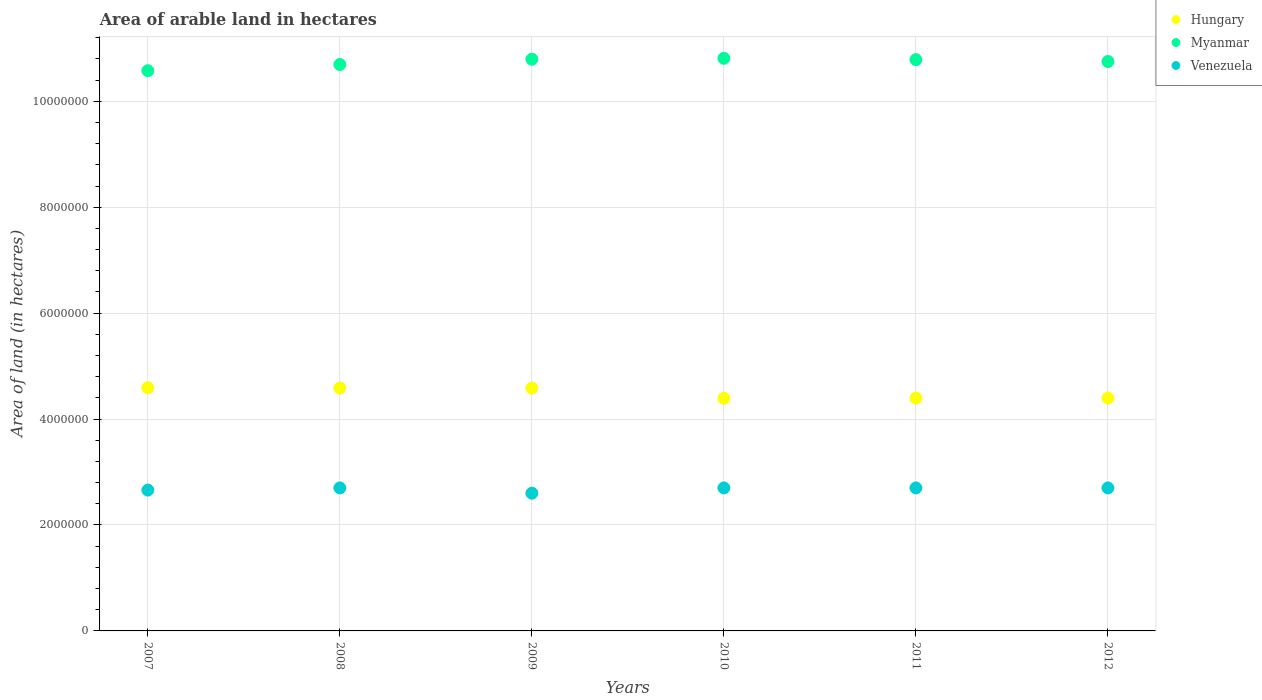What is the total arable land in Myanmar in 2010?
Provide a short and direct response. 1.08e+07. Across all years, what is the maximum total arable land in Hungary?
Offer a very short reply. 4.59e+06. Across all years, what is the minimum total arable land in Venezuela?
Offer a very short reply. 2.60e+06. In which year was the total arable land in Venezuela minimum?
Your answer should be compact. 2009. What is the total total arable land in Hungary in the graph?
Make the answer very short. 2.69e+07. What is the difference between the total arable land in Myanmar in 2011 and the total arable land in Hungary in 2008?
Provide a succinct answer. 6.20e+06. What is the average total arable land in Hungary per year?
Your response must be concise. 4.49e+06. In the year 2008, what is the difference between the total arable land in Venezuela and total arable land in Hungary?
Your answer should be very brief. -1.88e+06. What is the ratio of the total arable land in Venezuela in 2007 to that in 2010?
Your answer should be compact. 0.98. Is the total arable land in Hungary in 2007 less than that in 2011?
Provide a succinct answer. No. Is the difference between the total arable land in Venezuela in 2007 and 2012 greater than the difference between the total arable land in Hungary in 2007 and 2012?
Offer a very short reply. No. What is the difference between the highest and the second highest total arable land in Myanmar?
Your response must be concise. 1.70e+04. What is the difference between the highest and the lowest total arable land in Venezuela?
Keep it short and to the point. 1.00e+05. Is the sum of the total arable land in Venezuela in 2011 and 2012 greater than the maximum total arable land in Hungary across all years?
Ensure brevity in your answer.  Yes. Is the total arable land in Myanmar strictly greater than the total arable land in Hungary over the years?
Offer a very short reply. Yes. How many dotlines are there?
Offer a very short reply. 3. Does the graph contain any zero values?
Make the answer very short. No. Does the graph contain grids?
Your answer should be very brief. Yes. Where does the legend appear in the graph?
Provide a succinct answer. Top right. How many legend labels are there?
Give a very brief answer. 3. What is the title of the graph?
Give a very brief answer. Area of arable land in hectares. What is the label or title of the Y-axis?
Offer a terse response. Area of land (in hectares). What is the Area of land (in hectares) in Hungary in 2007?
Keep it short and to the point. 4.59e+06. What is the Area of land (in hectares) of Myanmar in 2007?
Your response must be concise. 1.06e+07. What is the Area of land (in hectares) in Venezuela in 2007?
Make the answer very short. 2.66e+06. What is the Area of land (in hectares) in Hungary in 2008?
Keep it short and to the point. 4.58e+06. What is the Area of land (in hectares) of Myanmar in 2008?
Keep it short and to the point. 1.07e+07. What is the Area of land (in hectares) of Venezuela in 2008?
Offer a terse response. 2.70e+06. What is the Area of land (in hectares) of Hungary in 2009?
Your answer should be compact. 4.58e+06. What is the Area of land (in hectares) of Myanmar in 2009?
Your answer should be very brief. 1.08e+07. What is the Area of land (in hectares) in Venezuela in 2009?
Offer a very short reply. 2.60e+06. What is the Area of land (in hectares) in Hungary in 2010?
Your answer should be compact. 4.39e+06. What is the Area of land (in hectares) in Myanmar in 2010?
Give a very brief answer. 1.08e+07. What is the Area of land (in hectares) in Venezuela in 2010?
Your answer should be very brief. 2.70e+06. What is the Area of land (in hectares) of Hungary in 2011?
Give a very brief answer. 4.40e+06. What is the Area of land (in hectares) in Myanmar in 2011?
Offer a terse response. 1.08e+07. What is the Area of land (in hectares) in Venezuela in 2011?
Your answer should be very brief. 2.70e+06. What is the Area of land (in hectares) of Hungary in 2012?
Provide a short and direct response. 4.40e+06. What is the Area of land (in hectares) in Myanmar in 2012?
Your answer should be compact. 1.08e+07. What is the Area of land (in hectares) of Venezuela in 2012?
Provide a short and direct response. 2.70e+06. Across all years, what is the maximum Area of land (in hectares) in Hungary?
Keep it short and to the point. 4.59e+06. Across all years, what is the maximum Area of land (in hectares) of Myanmar?
Your answer should be very brief. 1.08e+07. Across all years, what is the maximum Area of land (in hectares) of Venezuela?
Your answer should be compact. 2.70e+06. Across all years, what is the minimum Area of land (in hectares) in Hungary?
Make the answer very short. 4.39e+06. Across all years, what is the minimum Area of land (in hectares) in Myanmar?
Offer a very short reply. 1.06e+07. Across all years, what is the minimum Area of land (in hectares) of Venezuela?
Offer a terse response. 2.60e+06. What is the total Area of land (in hectares) in Hungary in the graph?
Your response must be concise. 2.69e+07. What is the total Area of land (in hectares) of Myanmar in the graph?
Offer a very short reply. 6.44e+07. What is the total Area of land (in hectares) in Venezuela in the graph?
Your answer should be very brief. 1.61e+07. What is the difference between the Area of land (in hectares) in Hungary in 2007 and that in 2008?
Your answer should be very brief. 7000. What is the difference between the Area of land (in hectares) in Myanmar in 2007 and that in 2008?
Your answer should be very brief. -1.17e+05. What is the difference between the Area of land (in hectares) of Venezuela in 2007 and that in 2008?
Offer a terse response. -4.10e+04. What is the difference between the Area of land (in hectares) in Hungary in 2007 and that in 2009?
Offer a terse response. 7000. What is the difference between the Area of land (in hectares) in Myanmar in 2007 and that in 2009?
Your answer should be compact. -2.17e+05. What is the difference between the Area of land (in hectares) in Venezuela in 2007 and that in 2009?
Keep it short and to the point. 5.90e+04. What is the difference between the Area of land (in hectares) of Myanmar in 2007 and that in 2010?
Your response must be concise. -2.34e+05. What is the difference between the Area of land (in hectares) in Venezuela in 2007 and that in 2010?
Ensure brevity in your answer.  -4.10e+04. What is the difference between the Area of land (in hectares) in Hungary in 2007 and that in 2011?
Provide a short and direct response. 1.97e+05. What is the difference between the Area of land (in hectares) of Myanmar in 2007 and that in 2011?
Make the answer very short. -2.09e+05. What is the difference between the Area of land (in hectares) in Venezuela in 2007 and that in 2011?
Keep it short and to the point. -4.10e+04. What is the difference between the Area of land (in hectares) in Hungary in 2007 and that in 2012?
Give a very brief answer. 1.95e+05. What is the difference between the Area of land (in hectares) in Myanmar in 2007 and that in 2012?
Give a very brief answer. -1.74e+05. What is the difference between the Area of land (in hectares) in Venezuela in 2007 and that in 2012?
Keep it short and to the point. -4.10e+04. What is the difference between the Area of land (in hectares) of Hungary in 2008 and that in 2010?
Keep it short and to the point. 1.93e+05. What is the difference between the Area of land (in hectares) of Myanmar in 2008 and that in 2010?
Provide a short and direct response. -1.17e+05. What is the difference between the Area of land (in hectares) in Hungary in 2008 and that in 2011?
Your response must be concise. 1.90e+05. What is the difference between the Area of land (in hectares) in Myanmar in 2008 and that in 2011?
Offer a terse response. -9.20e+04. What is the difference between the Area of land (in hectares) of Venezuela in 2008 and that in 2011?
Provide a succinct answer. 0. What is the difference between the Area of land (in hectares) in Hungary in 2008 and that in 2012?
Keep it short and to the point. 1.88e+05. What is the difference between the Area of land (in hectares) in Myanmar in 2008 and that in 2012?
Ensure brevity in your answer.  -5.70e+04. What is the difference between the Area of land (in hectares) in Hungary in 2009 and that in 2010?
Your answer should be very brief. 1.93e+05. What is the difference between the Area of land (in hectares) in Myanmar in 2009 and that in 2010?
Offer a very short reply. -1.70e+04. What is the difference between the Area of land (in hectares) of Hungary in 2009 and that in 2011?
Give a very brief answer. 1.90e+05. What is the difference between the Area of land (in hectares) of Myanmar in 2009 and that in 2011?
Your answer should be compact. 8000. What is the difference between the Area of land (in hectares) in Venezuela in 2009 and that in 2011?
Offer a terse response. -1.00e+05. What is the difference between the Area of land (in hectares) in Hungary in 2009 and that in 2012?
Keep it short and to the point. 1.88e+05. What is the difference between the Area of land (in hectares) of Myanmar in 2009 and that in 2012?
Ensure brevity in your answer.  4.30e+04. What is the difference between the Area of land (in hectares) of Hungary in 2010 and that in 2011?
Make the answer very short. -3000. What is the difference between the Area of land (in hectares) in Myanmar in 2010 and that in 2011?
Provide a succinct answer. 2.50e+04. What is the difference between the Area of land (in hectares) of Venezuela in 2010 and that in 2011?
Offer a terse response. 0. What is the difference between the Area of land (in hectares) in Hungary in 2010 and that in 2012?
Keep it short and to the point. -5000. What is the difference between the Area of land (in hectares) of Myanmar in 2010 and that in 2012?
Keep it short and to the point. 6.00e+04. What is the difference between the Area of land (in hectares) in Hungary in 2011 and that in 2012?
Make the answer very short. -2000. What is the difference between the Area of land (in hectares) in Myanmar in 2011 and that in 2012?
Make the answer very short. 3.50e+04. What is the difference between the Area of land (in hectares) of Venezuela in 2011 and that in 2012?
Your answer should be very brief. 0. What is the difference between the Area of land (in hectares) in Hungary in 2007 and the Area of land (in hectares) in Myanmar in 2008?
Your answer should be very brief. -6.10e+06. What is the difference between the Area of land (in hectares) of Hungary in 2007 and the Area of land (in hectares) of Venezuela in 2008?
Offer a terse response. 1.89e+06. What is the difference between the Area of land (in hectares) of Myanmar in 2007 and the Area of land (in hectares) of Venezuela in 2008?
Your answer should be compact. 7.88e+06. What is the difference between the Area of land (in hectares) of Hungary in 2007 and the Area of land (in hectares) of Myanmar in 2009?
Your answer should be compact. -6.20e+06. What is the difference between the Area of land (in hectares) in Hungary in 2007 and the Area of land (in hectares) in Venezuela in 2009?
Offer a very short reply. 1.99e+06. What is the difference between the Area of land (in hectares) of Myanmar in 2007 and the Area of land (in hectares) of Venezuela in 2009?
Make the answer very short. 7.98e+06. What is the difference between the Area of land (in hectares) of Hungary in 2007 and the Area of land (in hectares) of Myanmar in 2010?
Offer a terse response. -6.22e+06. What is the difference between the Area of land (in hectares) in Hungary in 2007 and the Area of land (in hectares) in Venezuela in 2010?
Your response must be concise. 1.89e+06. What is the difference between the Area of land (in hectares) in Myanmar in 2007 and the Area of land (in hectares) in Venezuela in 2010?
Give a very brief answer. 7.88e+06. What is the difference between the Area of land (in hectares) of Hungary in 2007 and the Area of land (in hectares) of Myanmar in 2011?
Your response must be concise. -6.19e+06. What is the difference between the Area of land (in hectares) in Hungary in 2007 and the Area of land (in hectares) in Venezuela in 2011?
Make the answer very short. 1.89e+06. What is the difference between the Area of land (in hectares) of Myanmar in 2007 and the Area of land (in hectares) of Venezuela in 2011?
Ensure brevity in your answer.  7.88e+06. What is the difference between the Area of land (in hectares) in Hungary in 2007 and the Area of land (in hectares) in Myanmar in 2012?
Your answer should be very brief. -6.16e+06. What is the difference between the Area of land (in hectares) of Hungary in 2007 and the Area of land (in hectares) of Venezuela in 2012?
Give a very brief answer. 1.89e+06. What is the difference between the Area of land (in hectares) in Myanmar in 2007 and the Area of land (in hectares) in Venezuela in 2012?
Offer a terse response. 7.88e+06. What is the difference between the Area of land (in hectares) in Hungary in 2008 and the Area of land (in hectares) in Myanmar in 2009?
Offer a terse response. -6.21e+06. What is the difference between the Area of land (in hectares) in Hungary in 2008 and the Area of land (in hectares) in Venezuela in 2009?
Your answer should be very brief. 1.98e+06. What is the difference between the Area of land (in hectares) in Myanmar in 2008 and the Area of land (in hectares) in Venezuela in 2009?
Keep it short and to the point. 8.09e+06. What is the difference between the Area of land (in hectares) in Hungary in 2008 and the Area of land (in hectares) in Myanmar in 2010?
Provide a short and direct response. -6.23e+06. What is the difference between the Area of land (in hectares) in Hungary in 2008 and the Area of land (in hectares) in Venezuela in 2010?
Offer a terse response. 1.88e+06. What is the difference between the Area of land (in hectares) of Myanmar in 2008 and the Area of land (in hectares) of Venezuela in 2010?
Keep it short and to the point. 7.99e+06. What is the difference between the Area of land (in hectares) of Hungary in 2008 and the Area of land (in hectares) of Myanmar in 2011?
Provide a short and direct response. -6.20e+06. What is the difference between the Area of land (in hectares) in Hungary in 2008 and the Area of land (in hectares) in Venezuela in 2011?
Offer a terse response. 1.88e+06. What is the difference between the Area of land (in hectares) of Myanmar in 2008 and the Area of land (in hectares) of Venezuela in 2011?
Keep it short and to the point. 7.99e+06. What is the difference between the Area of land (in hectares) of Hungary in 2008 and the Area of land (in hectares) of Myanmar in 2012?
Your answer should be compact. -6.17e+06. What is the difference between the Area of land (in hectares) in Hungary in 2008 and the Area of land (in hectares) in Venezuela in 2012?
Offer a terse response. 1.88e+06. What is the difference between the Area of land (in hectares) of Myanmar in 2008 and the Area of land (in hectares) of Venezuela in 2012?
Give a very brief answer. 7.99e+06. What is the difference between the Area of land (in hectares) in Hungary in 2009 and the Area of land (in hectares) in Myanmar in 2010?
Offer a very short reply. -6.23e+06. What is the difference between the Area of land (in hectares) of Hungary in 2009 and the Area of land (in hectares) of Venezuela in 2010?
Ensure brevity in your answer.  1.88e+06. What is the difference between the Area of land (in hectares) in Myanmar in 2009 and the Area of land (in hectares) in Venezuela in 2010?
Provide a succinct answer. 8.09e+06. What is the difference between the Area of land (in hectares) of Hungary in 2009 and the Area of land (in hectares) of Myanmar in 2011?
Keep it short and to the point. -6.20e+06. What is the difference between the Area of land (in hectares) in Hungary in 2009 and the Area of land (in hectares) in Venezuela in 2011?
Keep it short and to the point. 1.88e+06. What is the difference between the Area of land (in hectares) in Myanmar in 2009 and the Area of land (in hectares) in Venezuela in 2011?
Your response must be concise. 8.09e+06. What is the difference between the Area of land (in hectares) of Hungary in 2009 and the Area of land (in hectares) of Myanmar in 2012?
Offer a terse response. -6.17e+06. What is the difference between the Area of land (in hectares) in Hungary in 2009 and the Area of land (in hectares) in Venezuela in 2012?
Give a very brief answer. 1.88e+06. What is the difference between the Area of land (in hectares) in Myanmar in 2009 and the Area of land (in hectares) in Venezuela in 2012?
Offer a very short reply. 8.09e+06. What is the difference between the Area of land (in hectares) in Hungary in 2010 and the Area of land (in hectares) in Myanmar in 2011?
Your answer should be compact. -6.39e+06. What is the difference between the Area of land (in hectares) of Hungary in 2010 and the Area of land (in hectares) of Venezuela in 2011?
Offer a terse response. 1.69e+06. What is the difference between the Area of land (in hectares) in Myanmar in 2010 and the Area of land (in hectares) in Venezuela in 2011?
Your answer should be very brief. 8.11e+06. What is the difference between the Area of land (in hectares) of Hungary in 2010 and the Area of land (in hectares) of Myanmar in 2012?
Your answer should be compact. -6.36e+06. What is the difference between the Area of land (in hectares) in Hungary in 2010 and the Area of land (in hectares) in Venezuela in 2012?
Give a very brief answer. 1.69e+06. What is the difference between the Area of land (in hectares) in Myanmar in 2010 and the Area of land (in hectares) in Venezuela in 2012?
Keep it short and to the point. 8.11e+06. What is the difference between the Area of land (in hectares) in Hungary in 2011 and the Area of land (in hectares) in Myanmar in 2012?
Your answer should be compact. -6.36e+06. What is the difference between the Area of land (in hectares) of Hungary in 2011 and the Area of land (in hectares) of Venezuela in 2012?
Provide a short and direct response. 1.70e+06. What is the difference between the Area of land (in hectares) in Myanmar in 2011 and the Area of land (in hectares) in Venezuela in 2012?
Offer a terse response. 8.09e+06. What is the average Area of land (in hectares) in Hungary per year?
Offer a terse response. 4.49e+06. What is the average Area of land (in hectares) in Myanmar per year?
Your answer should be very brief. 1.07e+07. What is the average Area of land (in hectares) in Venezuela per year?
Provide a succinct answer. 2.68e+06. In the year 2007, what is the difference between the Area of land (in hectares) of Hungary and Area of land (in hectares) of Myanmar?
Give a very brief answer. -5.98e+06. In the year 2007, what is the difference between the Area of land (in hectares) in Hungary and Area of land (in hectares) in Venezuela?
Your response must be concise. 1.93e+06. In the year 2007, what is the difference between the Area of land (in hectares) in Myanmar and Area of land (in hectares) in Venezuela?
Make the answer very short. 7.92e+06. In the year 2008, what is the difference between the Area of land (in hectares) of Hungary and Area of land (in hectares) of Myanmar?
Provide a short and direct response. -6.11e+06. In the year 2008, what is the difference between the Area of land (in hectares) in Hungary and Area of land (in hectares) in Venezuela?
Your answer should be compact. 1.88e+06. In the year 2008, what is the difference between the Area of land (in hectares) of Myanmar and Area of land (in hectares) of Venezuela?
Keep it short and to the point. 7.99e+06. In the year 2009, what is the difference between the Area of land (in hectares) of Hungary and Area of land (in hectares) of Myanmar?
Your answer should be compact. -6.21e+06. In the year 2009, what is the difference between the Area of land (in hectares) in Hungary and Area of land (in hectares) in Venezuela?
Make the answer very short. 1.98e+06. In the year 2009, what is the difference between the Area of land (in hectares) in Myanmar and Area of land (in hectares) in Venezuela?
Your answer should be very brief. 8.19e+06. In the year 2010, what is the difference between the Area of land (in hectares) in Hungary and Area of land (in hectares) in Myanmar?
Your answer should be very brief. -6.42e+06. In the year 2010, what is the difference between the Area of land (in hectares) of Hungary and Area of land (in hectares) of Venezuela?
Offer a terse response. 1.69e+06. In the year 2010, what is the difference between the Area of land (in hectares) in Myanmar and Area of land (in hectares) in Venezuela?
Make the answer very short. 8.11e+06. In the year 2011, what is the difference between the Area of land (in hectares) in Hungary and Area of land (in hectares) in Myanmar?
Give a very brief answer. -6.39e+06. In the year 2011, what is the difference between the Area of land (in hectares) in Hungary and Area of land (in hectares) in Venezuela?
Give a very brief answer. 1.70e+06. In the year 2011, what is the difference between the Area of land (in hectares) in Myanmar and Area of land (in hectares) in Venezuela?
Your answer should be very brief. 8.09e+06. In the year 2012, what is the difference between the Area of land (in hectares) in Hungary and Area of land (in hectares) in Myanmar?
Your answer should be compact. -6.35e+06. In the year 2012, what is the difference between the Area of land (in hectares) of Hungary and Area of land (in hectares) of Venezuela?
Your answer should be compact. 1.70e+06. In the year 2012, what is the difference between the Area of land (in hectares) in Myanmar and Area of land (in hectares) in Venezuela?
Provide a succinct answer. 8.05e+06. What is the ratio of the Area of land (in hectares) of Hungary in 2007 to that in 2008?
Keep it short and to the point. 1. What is the ratio of the Area of land (in hectares) in Venezuela in 2007 to that in 2008?
Provide a short and direct response. 0.98. What is the ratio of the Area of land (in hectares) of Myanmar in 2007 to that in 2009?
Your response must be concise. 0.98. What is the ratio of the Area of land (in hectares) of Venezuela in 2007 to that in 2009?
Provide a succinct answer. 1.02. What is the ratio of the Area of land (in hectares) in Hungary in 2007 to that in 2010?
Offer a terse response. 1.05. What is the ratio of the Area of land (in hectares) of Myanmar in 2007 to that in 2010?
Offer a very short reply. 0.98. What is the ratio of the Area of land (in hectares) of Hungary in 2007 to that in 2011?
Provide a succinct answer. 1.04. What is the ratio of the Area of land (in hectares) in Myanmar in 2007 to that in 2011?
Provide a succinct answer. 0.98. What is the ratio of the Area of land (in hectares) in Venezuela in 2007 to that in 2011?
Provide a succinct answer. 0.98. What is the ratio of the Area of land (in hectares) in Hungary in 2007 to that in 2012?
Provide a succinct answer. 1.04. What is the ratio of the Area of land (in hectares) in Myanmar in 2007 to that in 2012?
Offer a terse response. 0.98. What is the ratio of the Area of land (in hectares) in Myanmar in 2008 to that in 2009?
Ensure brevity in your answer.  0.99. What is the ratio of the Area of land (in hectares) in Venezuela in 2008 to that in 2009?
Provide a short and direct response. 1.04. What is the ratio of the Area of land (in hectares) in Hungary in 2008 to that in 2010?
Provide a short and direct response. 1.04. What is the ratio of the Area of land (in hectares) of Myanmar in 2008 to that in 2010?
Offer a very short reply. 0.99. What is the ratio of the Area of land (in hectares) in Hungary in 2008 to that in 2011?
Your response must be concise. 1.04. What is the ratio of the Area of land (in hectares) in Myanmar in 2008 to that in 2011?
Keep it short and to the point. 0.99. What is the ratio of the Area of land (in hectares) of Hungary in 2008 to that in 2012?
Ensure brevity in your answer.  1.04. What is the ratio of the Area of land (in hectares) of Myanmar in 2008 to that in 2012?
Offer a terse response. 0.99. What is the ratio of the Area of land (in hectares) of Hungary in 2009 to that in 2010?
Keep it short and to the point. 1.04. What is the ratio of the Area of land (in hectares) in Hungary in 2009 to that in 2011?
Make the answer very short. 1.04. What is the ratio of the Area of land (in hectares) in Myanmar in 2009 to that in 2011?
Give a very brief answer. 1. What is the ratio of the Area of land (in hectares) of Venezuela in 2009 to that in 2011?
Offer a very short reply. 0.96. What is the ratio of the Area of land (in hectares) in Hungary in 2009 to that in 2012?
Your answer should be compact. 1.04. What is the ratio of the Area of land (in hectares) in Myanmar in 2009 to that in 2012?
Your response must be concise. 1. What is the ratio of the Area of land (in hectares) in Myanmar in 2010 to that in 2011?
Offer a terse response. 1. What is the ratio of the Area of land (in hectares) of Hungary in 2010 to that in 2012?
Your response must be concise. 1. What is the ratio of the Area of land (in hectares) in Myanmar in 2010 to that in 2012?
Keep it short and to the point. 1.01. What is the ratio of the Area of land (in hectares) of Hungary in 2011 to that in 2012?
Offer a terse response. 1. What is the ratio of the Area of land (in hectares) in Venezuela in 2011 to that in 2012?
Provide a succinct answer. 1. What is the difference between the highest and the second highest Area of land (in hectares) in Hungary?
Ensure brevity in your answer.  7000. What is the difference between the highest and the second highest Area of land (in hectares) in Myanmar?
Offer a terse response. 1.70e+04. What is the difference between the highest and the lowest Area of land (in hectares) in Hungary?
Make the answer very short. 2.00e+05. What is the difference between the highest and the lowest Area of land (in hectares) in Myanmar?
Your answer should be compact. 2.34e+05. 